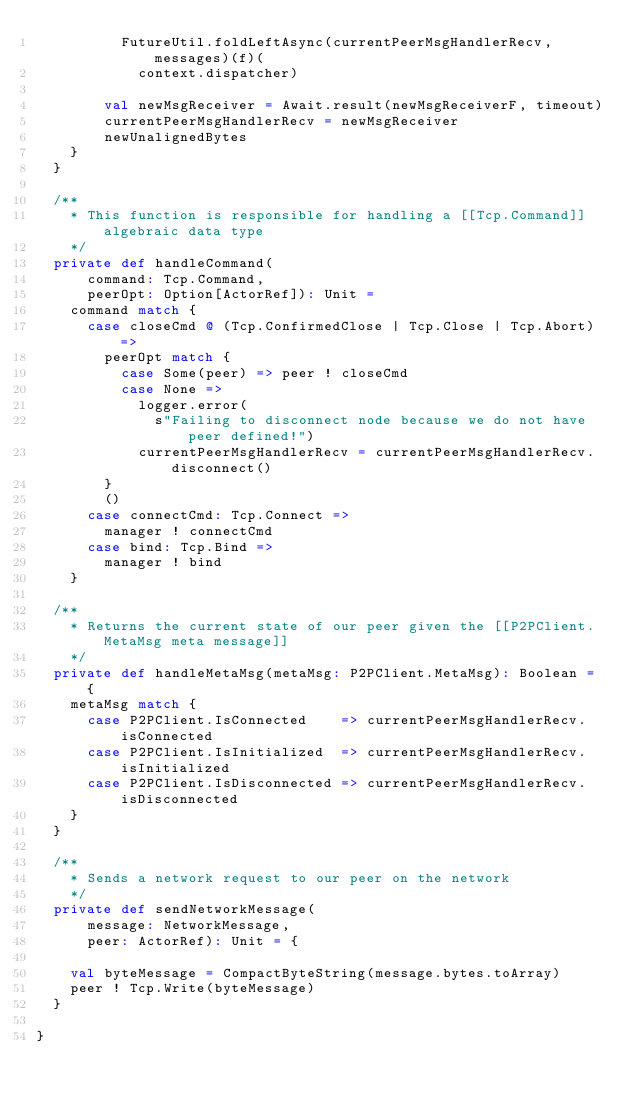Convert code to text. <code><loc_0><loc_0><loc_500><loc_500><_Scala_>          FutureUtil.foldLeftAsync(currentPeerMsgHandlerRecv, messages)(f)(
            context.dispatcher)

        val newMsgReceiver = Await.result(newMsgReceiverF, timeout)
        currentPeerMsgHandlerRecv = newMsgReceiver
        newUnalignedBytes
    }
  }

  /**
    * This function is responsible for handling a [[Tcp.Command]] algebraic data type
    */
  private def handleCommand(
      command: Tcp.Command,
      peerOpt: Option[ActorRef]): Unit =
    command match {
      case closeCmd @ (Tcp.ConfirmedClose | Tcp.Close | Tcp.Abort) =>
        peerOpt match {
          case Some(peer) => peer ! closeCmd
          case None =>
            logger.error(
              s"Failing to disconnect node because we do not have peer defined!")
            currentPeerMsgHandlerRecv = currentPeerMsgHandlerRecv.disconnect()
        }
        ()
      case connectCmd: Tcp.Connect =>
        manager ! connectCmd
      case bind: Tcp.Bind =>
        manager ! bind
    }

  /**
    * Returns the current state of our peer given the [[P2PClient.MetaMsg meta message]]
    */
  private def handleMetaMsg(metaMsg: P2PClient.MetaMsg): Boolean = {
    metaMsg match {
      case P2PClient.IsConnected    => currentPeerMsgHandlerRecv.isConnected
      case P2PClient.IsInitialized  => currentPeerMsgHandlerRecv.isInitialized
      case P2PClient.IsDisconnected => currentPeerMsgHandlerRecv.isDisconnected
    }
  }

  /**
    * Sends a network request to our peer on the network
    */
  private def sendNetworkMessage(
      message: NetworkMessage,
      peer: ActorRef): Unit = {

    val byteMessage = CompactByteString(message.bytes.toArray)
    peer ! Tcp.Write(byteMessage)
  }

}
</code> 